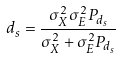<formula> <loc_0><loc_0><loc_500><loc_500>d _ { s } = \frac { \sigma _ { X } ^ { 2 } \sigma _ { E } ^ { 2 } P _ { d _ { s } } } { \sigma _ { X } ^ { 2 } + \sigma _ { E } ^ { 2 } P _ { d _ { s } } }</formula> 